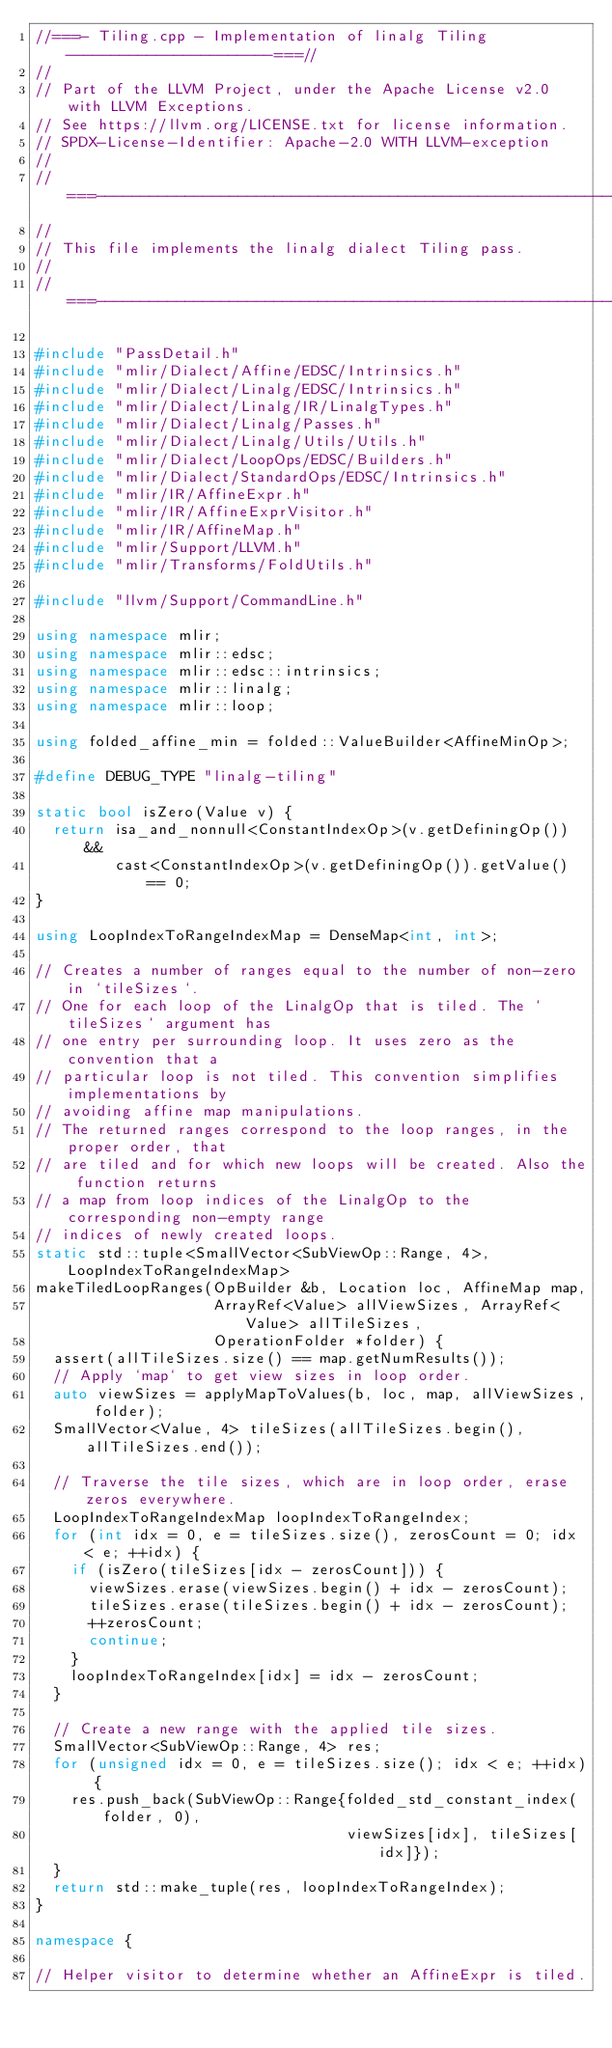Convert code to text. <code><loc_0><loc_0><loc_500><loc_500><_C++_>//===- Tiling.cpp - Implementation of linalg Tiling -----------------------===//
//
// Part of the LLVM Project, under the Apache License v2.0 with LLVM Exceptions.
// See https://llvm.org/LICENSE.txt for license information.
// SPDX-License-Identifier: Apache-2.0 WITH LLVM-exception
//
//===----------------------------------------------------------------------===//
//
// This file implements the linalg dialect Tiling pass.
//
//===----------------------------------------------------------------------===//

#include "PassDetail.h"
#include "mlir/Dialect/Affine/EDSC/Intrinsics.h"
#include "mlir/Dialect/Linalg/EDSC/Intrinsics.h"
#include "mlir/Dialect/Linalg/IR/LinalgTypes.h"
#include "mlir/Dialect/Linalg/Passes.h"
#include "mlir/Dialect/Linalg/Utils/Utils.h"
#include "mlir/Dialect/LoopOps/EDSC/Builders.h"
#include "mlir/Dialect/StandardOps/EDSC/Intrinsics.h"
#include "mlir/IR/AffineExpr.h"
#include "mlir/IR/AffineExprVisitor.h"
#include "mlir/IR/AffineMap.h"
#include "mlir/Support/LLVM.h"
#include "mlir/Transforms/FoldUtils.h"

#include "llvm/Support/CommandLine.h"

using namespace mlir;
using namespace mlir::edsc;
using namespace mlir::edsc::intrinsics;
using namespace mlir::linalg;
using namespace mlir::loop;

using folded_affine_min = folded::ValueBuilder<AffineMinOp>;

#define DEBUG_TYPE "linalg-tiling"

static bool isZero(Value v) {
  return isa_and_nonnull<ConstantIndexOp>(v.getDefiningOp()) &&
         cast<ConstantIndexOp>(v.getDefiningOp()).getValue() == 0;
}

using LoopIndexToRangeIndexMap = DenseMap<int, int>;

// Creates a number of ranges equal to the number of non-zero in `tileSizes`.
// One for each loop of the LinalgOp that is tiled. The `tileSizes` argument has
// one entry per surrounding loop. It uses zero as the convention that a
// particular loop is not tiled. This convention simplifies implementations by
// avoiding affine map manipulations.
// The returned ranges correspond to the loop ranges, in the proper order, that
// are tiled and for which new loops will be created. Also the function returns
// a map from loop indices of the LinalgOp to the corresponding non-empty range
// indices of newly created loops.
static std::tuple<SmallVector<SubViewOp::Range, 4>, LoopIndexToRangeIndexMap>
makeTiledLoopRanges(OpBuilder &b, Location loc, AffineMap map,
                    ArrayRef<Value> allViewSizes, ArrayRef<Value> allTileSizes,
                    OperationFolder *folder) {
  assert(allTileSizes.size() == map.getNumResults());
  // Apply `map` to get view sizes in loop order.
  auto viewSizes = applyMapToValues(b, loc, map, allViewSizes, folder);
  SmallVector<Value, 4> tileSizes(allTileSizes.begin(), allTileSizes.end());

  // Traverse the tile sizes, which are in loop order, erase zeros everywhere.
  LoopIndexToRangeIndexMap loopIndexToRangeIndex;
  for (int idx = 0, e = tileSizes.size(), zerosCount = 0; idx < e; ++idx) {
    if (isZero(tileSizes[idx - zerosCount])) {
      viewSizes.erase(viewSizes.begin() + idx - zerosCount);
      tileSizes.erase(tileSizes.begin() + idx - zerosCount);
      ++zerosCount;
      continue;
    }
    loopIndexToRangeIndex[idx] = idx - zerosCount;
  }

  // Create a new range with the applied tile sizes.
  SmallVector<SubViewOp::Range, 4> res;
  for (unsigned idx = 0, e = tileSizes.size(); idx < e; ++idx) {
    res.push_back(SubViewOp::Range{folded_std_constant_index(folder, 0),
                                   viewSizes[idx], tileSizes[idx]});
  }
  return std::make_tuple(res, loopIndexToRangeIndex);
}

namespace {

// Helper visitor to determine whether an AffineExpr is tiled.</code> 